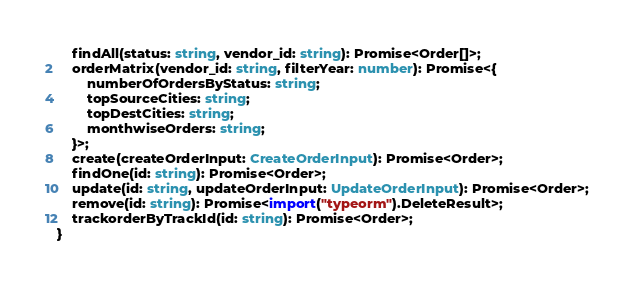Convert code to text. <code><loc_0><loc_0><loc_500><loc_500><_TypeScript_>    findAll(status: string, vendor_id: string): Promise<Order[]>;
    orderMatrix(vendor_id: string, filterYear: number): Promise<{
        numberOfOrdersByStatus: string;
        topSourceCities: string;
        topDestCities: string;
        monthwiseOrders: string;
    }>;
    create(createOrderInput: CreateOrderInput): Promise<Order>;
    findOne(id: string): Promise<Order>;
    update(id: string, updateOrderInput: UpdateOrderInput): Promise<Order>;
    remove(id: string): Promise<import("typeorm").DeleteResult>;
    trackorderByTrackId(id: string): Promise<Order>;
}
</code> 